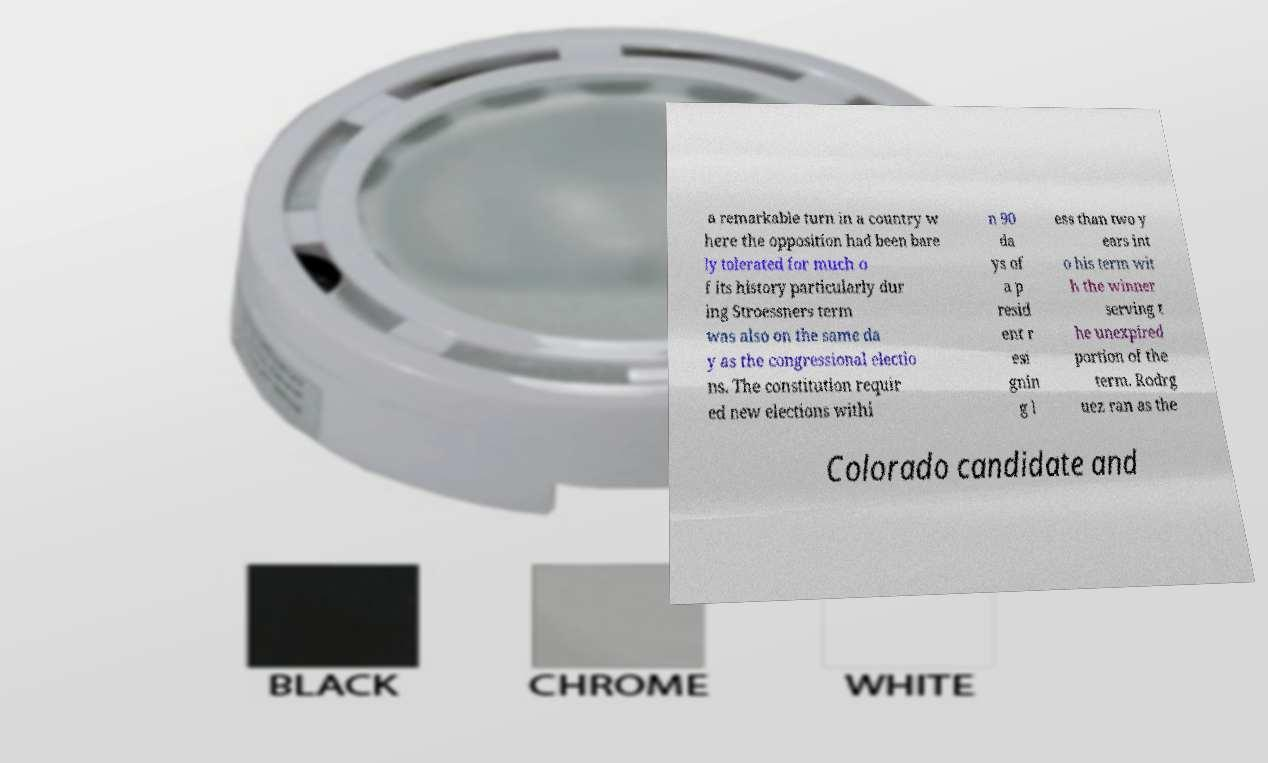Can you accurately transcribe the text from the provided image for me? a remarkable turn in a country w here the opposition had been bare ly tolerated for much o f its history particularly dur ing Stroessners term was also on the same da y as the congressional electio ns. The constitution requir ed new elections withi n 90 da ys of a p resid ent r esi gnin g l ess than two y ears int o his term wit h the winner serving t he unexpired portion of the term. Rodrg uez ran as the Colorado candidate and 